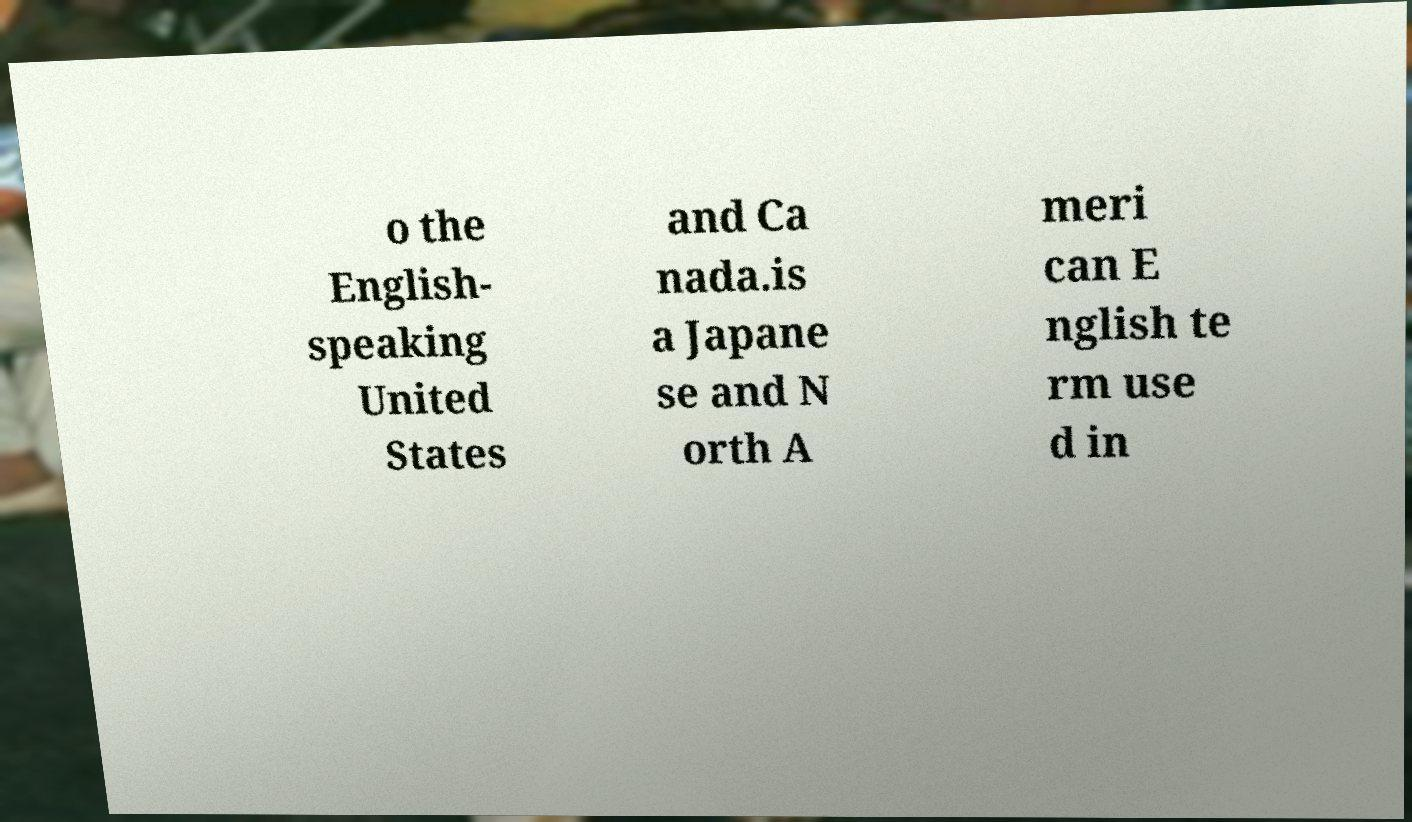There's text embedded in this image that I need extracted. Can you transcribe it verbatim? o the English- speaking United States and Ca nada.is a Japane se and N orth A meri can E nglish te rm use d in 